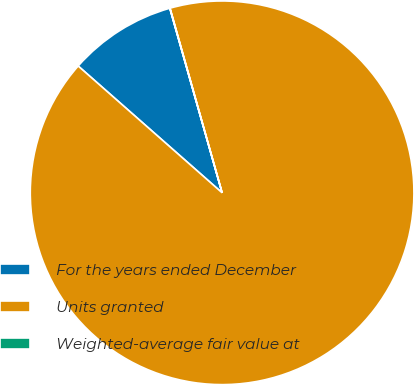Convert chart to OTSL. <chart><loc_0><loc_0><loc_500><loc_500><pie_chart><fcel>For the years ended December<fcel>Units granted<fcel>Weighted-average fair value at<nl><fcel>9.11%<fcel>90.87%<fcel>0.02%<nl></chart> 